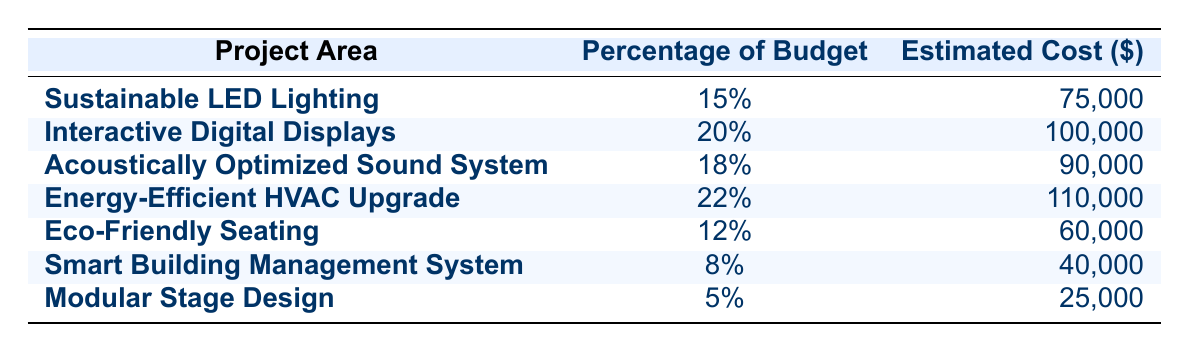What is the estimated cost for the Energy-Efficient HVAC Upgrade? The table shows the estimated cost for each project area. For the Energy-Efficient HVAC Upgrade, it is listed as 110,000.
Answer: 110,000 Which project area has the largest percentage of the budget allocation? Looking at the "Percentage of Budget" column, the Energy-Efficient HVAC Upgrade is allocated the highest percentage at 22%.
Answer: 22% What is the total estimated cost for all projects combined? To find the total estimated cost, we add all the estimated costs together: 75,000 + 100,000 + 90,000 + 110,000 + 60,000 + 40,000 + 25,000 = 500,000.
Answer: 500,000 Are Interactive Digital Displays allocated a higher budget percentage than Eco-Friendly Seating? The percentage for Interactive Digital Displays is 20%, and for Eco-Friendly Seating, it is 12%. Since 20% is greater than 12%, the statement is true.
Answer: Yes What is the average budget percentage across all project areas? To calculate the average, first, sum the percentages: 15% + 20% + 18% + 22% + 12% + 8% + 5% = 100%. Then, divide by the number of projects, which is 7: 100% / 7 = approximately 14.29%.
Answer: 14.29% Which two project areas combined represent more than 30% of the budget? Looking at the table, Energy-Efficient HVAC Upgrade (22%) combined with Interactive Digital Displays (20%) equals 42%, which is greater than 30%. Other combinations do not exceed 30%.
Answer: Energy-Efficient HVAC Upgrade and Interactive Digital Displays Is the cost of the Smart Building Management System less than the combined cost of Eco-Friendly Seating and Modular Stage Design? The cost of Smart Building Management System is 40,000. Eco-Friendly Seating is 60,000 and Modular Stage Design is 25,000. The combined cost is 60,000 + 25,000 = 85,000, which is greater than 40,000. Thus, the statement is true.
Answer: Yes What is the cost difference between the Acoustically Optimized Sound System and the Sustainable LED Lighting? The estimated cost for Acoustically Optimized Sound System is 90,000 and for Sustainable LED Lighting is 75,000. The difference is 90,000 - 75,000 = 15,000.
Answer: 15,000 